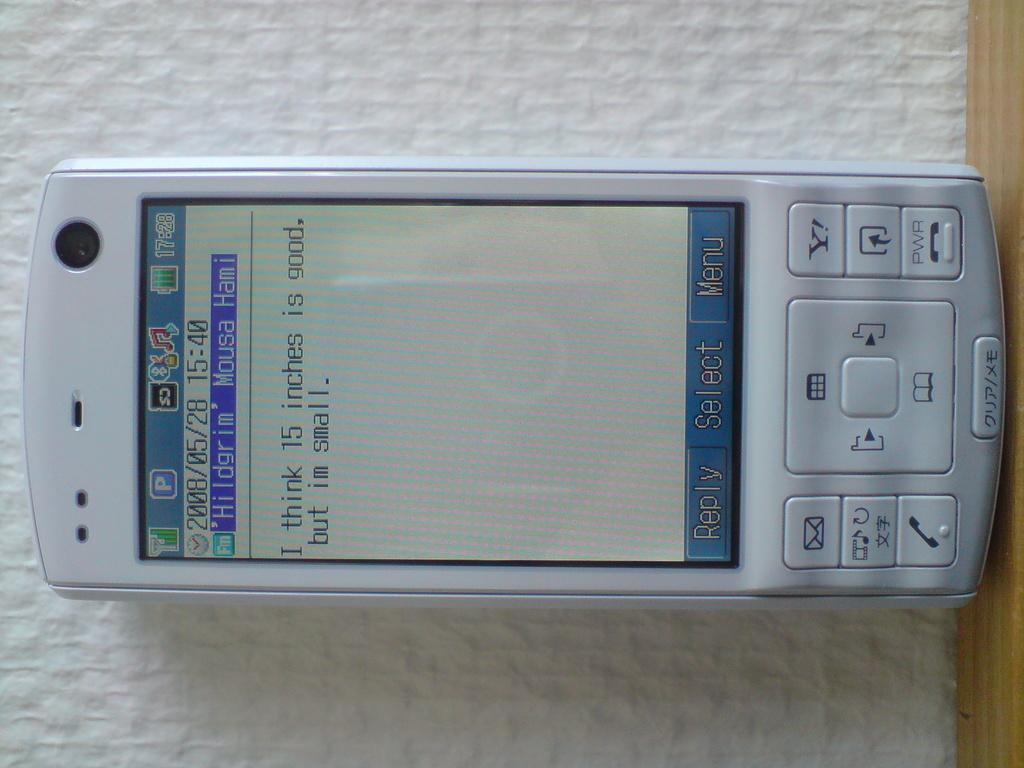<image>
Offer a succinct explanation of the picture presented. A device that says reply select and Menu across the bottom. 